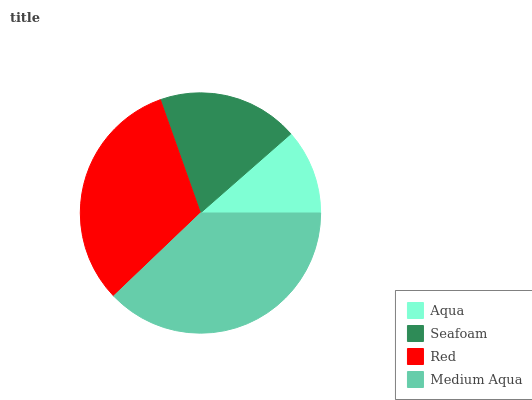Is Aqua the minimum?
Answer yes or no. Yes. Is Medium Aqua the maximum?
Answer yes or no. Yes. Is Seafoam the minimum?
Answer yes or no. No. Is Seafoam the maximum?
Answer yes or no. No. Is Seafoam greater than Aqua?
Answer yes or no. Yes. Is Aqua less than Seafoam?
Answer yes or no. Yes. Is Aqua greater than Seafoam?
Answer yes or no. No. Is Seafoam less than Aqua?
Answer yes or no. No. Is Red the high median?
Answer yes or no. Yes. Is Seafoam the low median?
Answer yes or no. Yes. Is Aqua the high median?
Answer yes or no. No. Is Aqua the low median?
Answer yes or no. No. 